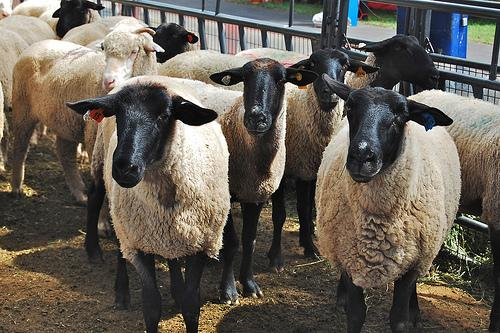What are the primary animals present in the image?  Several sheep are the primary animals in the image. Describe the ground inside the pen mentioned in the image. The ground inside the pen is a brown dirt floor. What is the habitat description of the sheep in the image? The sheep live in a pen with a brown dirt floor and a black metal fence. Which part of the fence is mentioned in both the image and the derived commonsense knowledge?  The black metal fence of the pen and the black metal rail of the fence are mentioned. What is the color of the sheep's heads mentioned in the image?  The heads of the sheep are black.  Identify two colors of the fur on the sheep.  Black and white fur is identified on the sheep. Count the sheep behind the fence in the image. A small herd of sheep are located behind the fence. How do the sheep in the image react to stimuli?  Four sheep are reacting attentively. Mention the color of the tags on the sheep's ears. There are white, red, yellow, and blue tags on the sheep's ears. Describe any peculiar feature of the hooves of the sheep. The hooves of the sheep are forked. Is there any grass visible in the image? If so, what color is it? Short green grass Which part of the sheep has the tags attached? Ears What type of barrier is used to keep the sheep within the pen? Fence Describe the expressions of the sheep in the pen. Attentive Using the information given, what might the sheep be reacting to? Unknown Is there a yellow bin outside of the pen? The bin described in the image is blue, not yellow. Are the sheep standing on a sandy beach? The ground is described as a brown dirt floor and short green grass, not a sandy beach. Describe the appearance of the sheep's legs in the image. Black legs and hooves Describe the material and color of the fence and rail.  Black metal From the information given, can you determine the direction the sheep are looking in? The sheep are looking in the same direction. Provide a clear caption of the objects in the image. Sheep with different ear tags standing in a pen with a dirt floor, black fence, and a blue bin outside. Create a short story that includes the sheep, the tags, and a blue bin. Once upon a time, in a small countryside village, a diverse group of sheep lived in a pen. They all had colorful tags on their ears: white, red, yellow, and blue. One day, they discovered an intriguing blue bin outside the pen that captured their attention. What's the distinguishing feature of a particular white sheep in the image?  It has horns. Is there a green sheep in the pen? No, it's not mentioned in the image. Using the image as reference, identify the object that is placed outside of the pen. A blue bin What is the color combination of a sheep with mixed fur in the image? White and black List all the different colored ear tags found on the sheep.  White, red, yellow, blue What are the sheep standing on in the image? Brown dirt floor Which type of flooring is present in the pen? Brown dirt What type of surface is there outside the pen? Paved road What animals are depicted in the image? Sheep Identify a shadow in the image and describe its source. Shadow of sheep Is there any notable tagged sheep whose head color differs from the others? A white sheep with a white head 